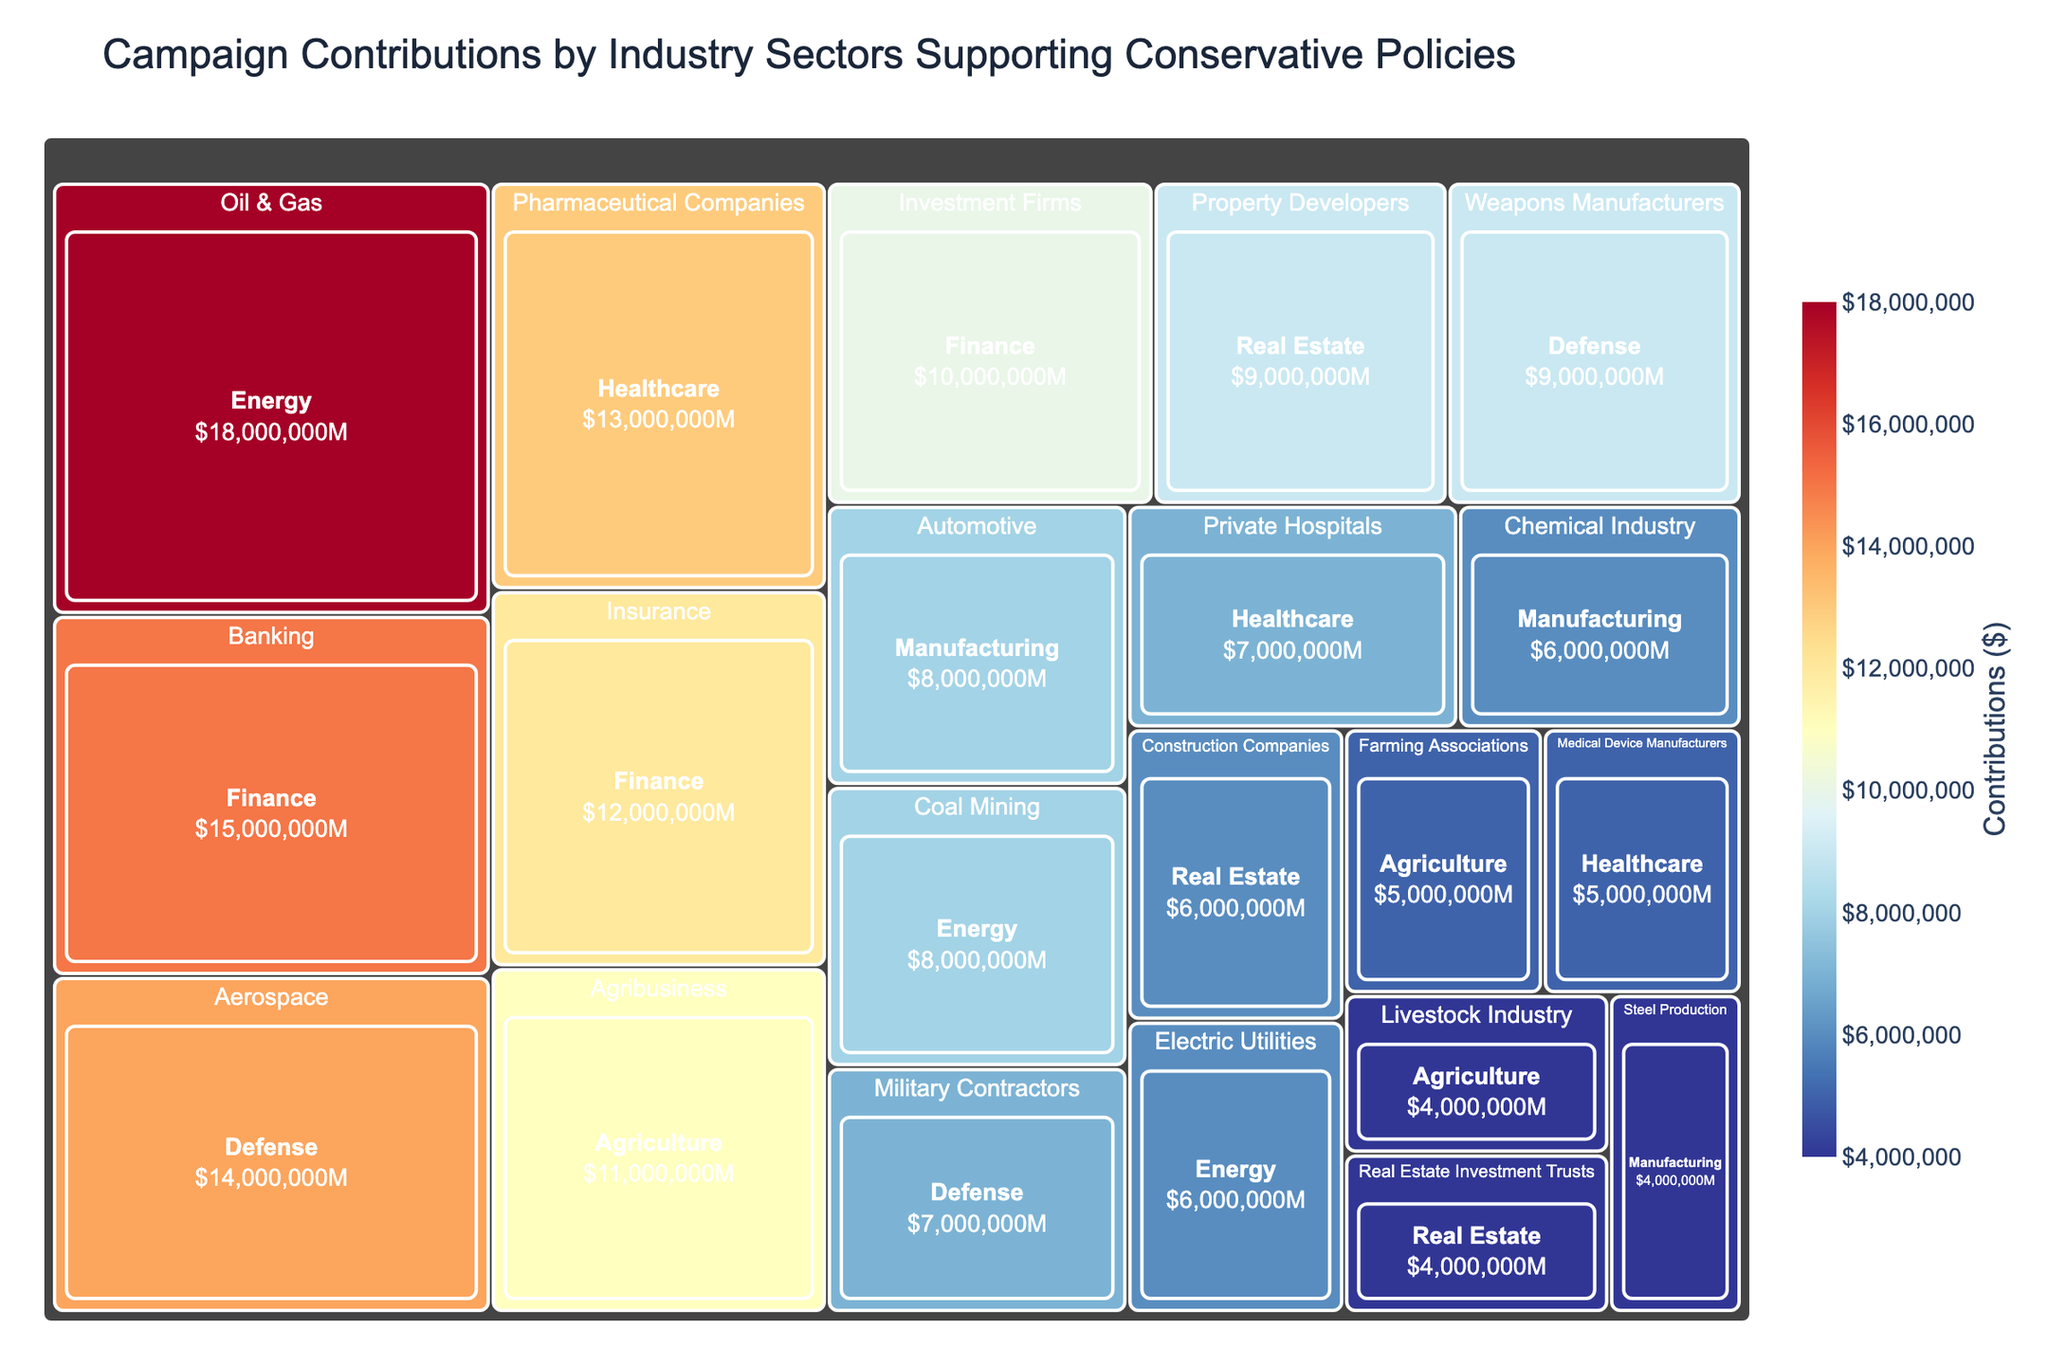What's the largest sector by campaign contributions? To find the largest sector by campaign contributions, we look for the sector with the largest-sized boxes in the treemap.
Answer: Energy What's the total contribution from the Finance sector? The Finance sector includes contributions from Banking, Insurance, and Investment Firms. Adding up these contributions: 15M (Banking) + 12M (Insurance) + 10M (Investment Firms) = 37M.
Answer: 37 million Which industry within the Defense sector received the highest contributions? Within the Defense sector, we compare Aerospace, Weapons Manufacturers, and Military Contractors. The highest contribution is from Aerospace at 14M.
Answer: Aerospace How do the contributions from Oil & Gas compare to the combined contributions of Coal Mining and Electric Utilities? Oil & Gas has 18M. Adding Coal Mining (8M) and Electric Utilities (6M) gives 14M, which is less than Oil & Gas.
Answer: Oil & Gas contributions are higher Which sector has the smallest total contributions? To identify the smallest sector, we compare the overall size of the sectors. The Real Estate sector appears smallest with combined contributions from Property Developers (9M), Construction Companies (6M), and Real Estate Investment Trusts (4M), totaling 19M.
Answer: Real Estate What is the average contribution of the sectors shown? First, sum up all the sector contributions and then divide by the number of sectors. Total contributions: 123M (Finance) + 32M (Agriculture) + 30M (Defense) + 18M (Manufacturing) + 25M (Healthcare) + 19M (Real Estate). Sum = 247M. There are 6 sectors. 247M / 6 = approx. 41.17M.
Answer: About 41.17 million Among the industries listed under Healthcare, which receives the least funding and by how much? Compare contributions for Pharmaceutical Companies (13M), Private Hospitals (7M), and Medical Device Manufacturers (5M). Medical Device Manufacturers receive the least at 5M.
Answer: Medical Device Manufacturers, 5M How much more does the Aerospace industry receive compared to the Livestock Industry? Aerospace has 14M, and Livestock Industry has 4M. The difference is 14M - 4M = 10M.
Answer: 10 million What's the average contribution for the industries within the Energy sector? First, sum up the contributions of the three industries: Oil & Gas (18M) + Coal Mining (8M) + Electric Utilities (6M) = 32M. There are 3 industries, so 32M / 3 = approx. 10.67M.
Answer: About 10.67 million 